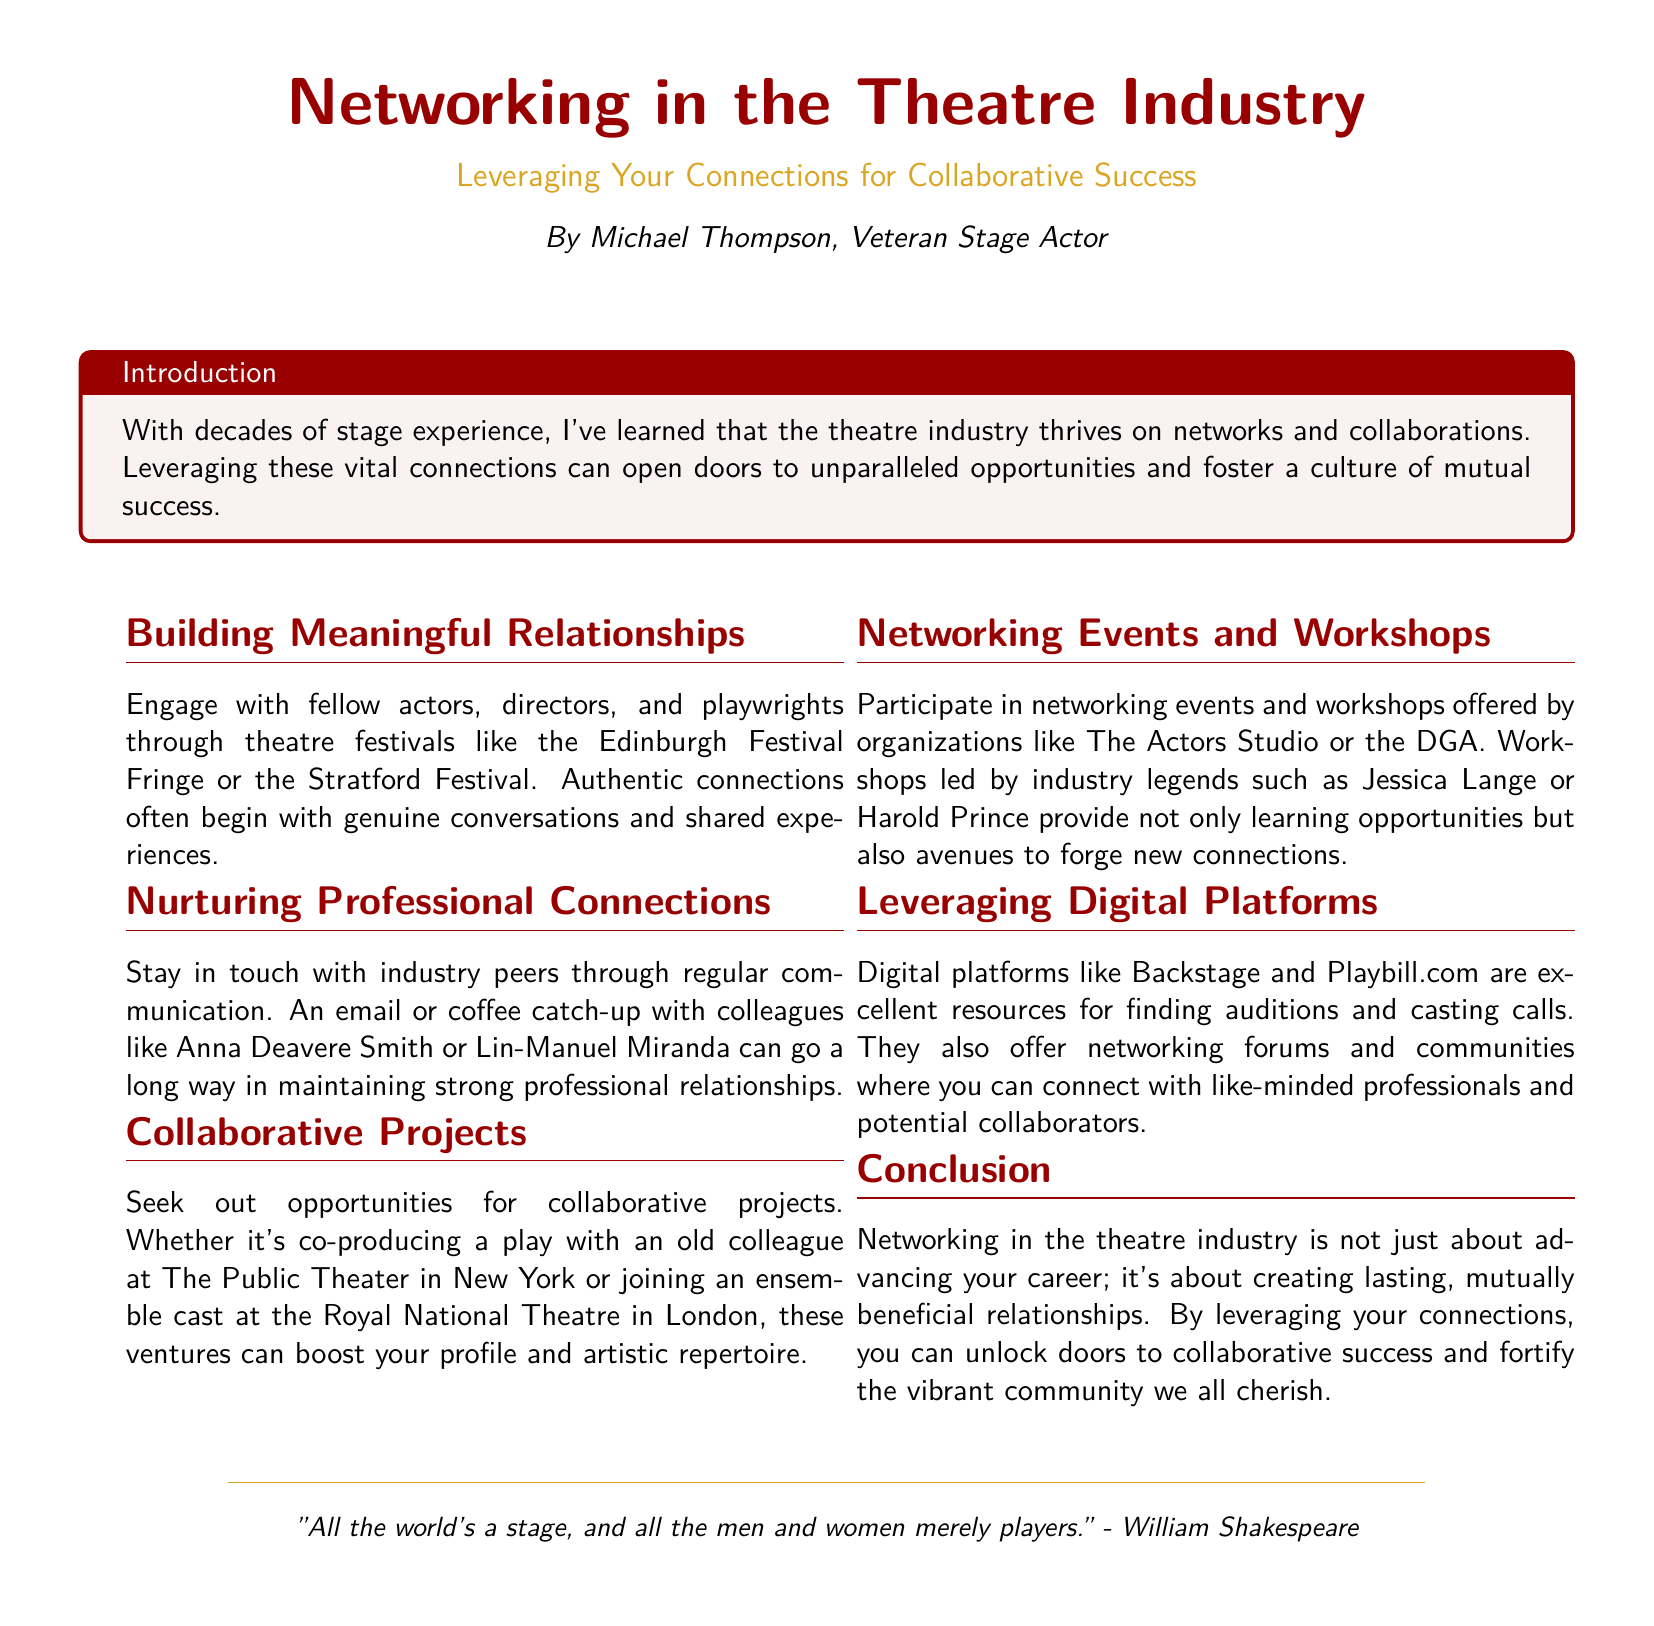What is the author’s name? The author, Michael Thompson, is introduced in the document as a veteran stage actor.
Answer: Michael Thompson What color is used for the title "Networking in the Theatre Industry"? The document specifies that the title is in theatreRed color.
Answer: theatreRed What types of events should you participate in for networking? The document mentions networking events and workshops as crucial for networking in the theatre industry.
Answer: Networking events and workshops Which famous theatre festival is mentioned for building relationships? The document refers to the Edinburgh Festival Fringe as a place to engage with fellow theatre professionals.
Answer: Edinburgh Festival Fringe Name one of the organizations offering workshops. The text mentions The Actors Studio as a relevant organization for networking workshops.
Answer: The Actors Studio Which two individuals are suggested to stay in touch with? The document lists Anna Deavere Smith and Lin-Manuel Miranda as industry peers to maintain connections with.
Answer: Anna Deavere Smith and Lin-Manuel Miranda What is a benefit of collaborative projects according to the document? The document states that collaborative projects can boost one’s profile and artistic repertoire.
Answer: Boost profile and artistic repertoire What is the concluding message about networking in the theatre industry? The conclusion states that networking is about creating lasting, mutually beneficial relationships.
Answer: Creating lasting, mutually beneficial relationships Which digital platforms are recommended for networking? Backstage and Playbill.com are specifically mentioned as excellent digital resources for networking.
Answer: Backstage and Playbill.com 